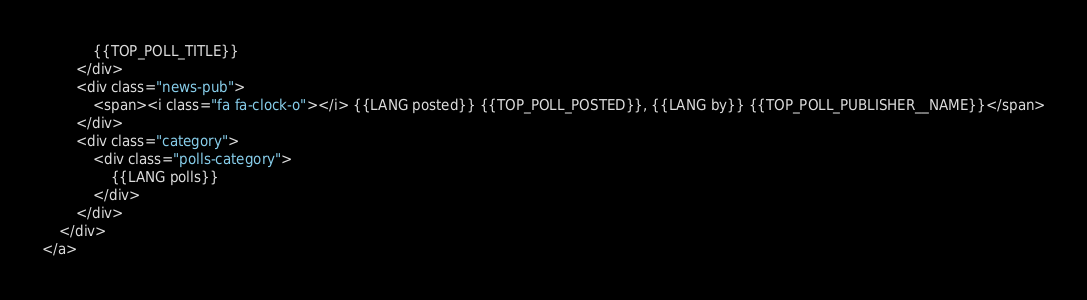<code> <loc_0><loc_0><loc_500><loc_500><_HTML_>			{{TOP_POLL_TITLE}}
		</div>
		<div class="news-pub">
			<span><i class="fa fa-clock-o"></i> {{LANG posted}} {{TOP_POLL_POSTED}}, {{LANG by}} {{TOP_POLL_PUBLISHER__NAME}}</span>
		</div>
		<div class="category">
			<div class="polls-category">
				{{LANG polls}}
			</div>
		</div>
	</div>
</a></code> 